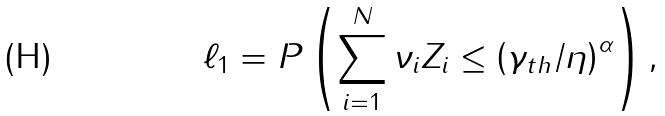<formula> <loc_0><loc_0><loc_500><loc_500>\ell _ { 1 } = P \left ( \sum _ { i = 1 } ^ { N } { \nu _ { i } Z _ { i } } \leq \left ( \gamma _ { t h } / \eta \right ) ^ { \alpha } \right ) ,</formula> 